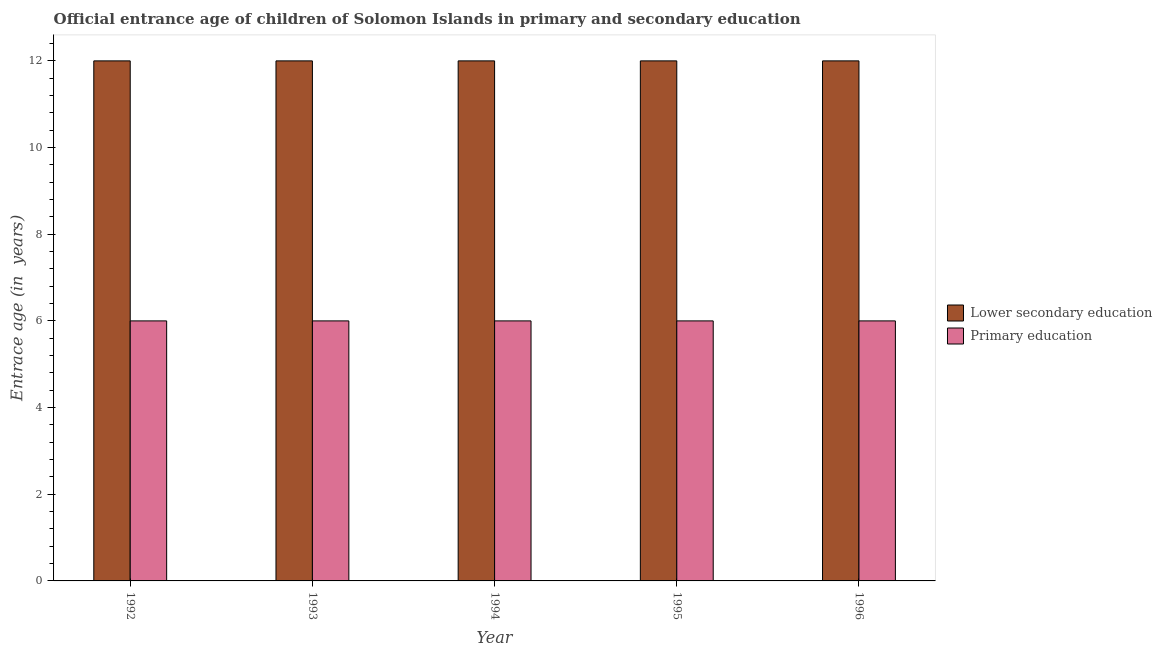How many different coloured bars are there?
Provide a short and direct response. 2. Are the number of bars per tick equal to the number of legend labels?
Offer a very short reply. Yes. What is the entrance age of children in lower secondary education in 1992?
Provide a short and direct response. 12. Across all years, what is the maximum entrance age of chiildren in primary education?
Ensure brevity in your answer.  6. In which year was the entrance age of chiildren in primary education maximum?
Provide a short and direct response. 1992. What is the total entrance age of chiildren in primary education in the graph?
Ensure brevity in your answer.  30. What is the difference between the entrance age of chiildren in primary education in 1994 and the entrance age of children in lower secondary education in 1995?
Ensure brevity in your answer.  0. In the year 1994, what is the difference between the entrance age of children in lower secondary education and entrance age of chiildren in primary education?
Make the answer very short. 0. In how many years, is the entrance age of chiildren in primary education greater than 10.4 years?
Your answer should be very brief. 0. Is the entrance age of chiildren in primary education in 1994 less than that in 1996?
Your answer should be very brief. No. What is the difference between the highest and the lowest entrance age of children in lower secondary education?
Provide a succinct answer. 0. In how many years, is the entrance age of chiildren in primary education greater than the average entrance age of chiildren in primary education taken over all years?
Your answer should be compact. 0. Is the sum of the entrance age of chiildren in primary education in 1994 and 1995 greater than the maximum entrance age of children in lower secondary education across all years?
Give a very brief answer. Yes. What does the 2nd bar from the right in 1993 represents?
Your response must be concise. Lower secondary education. Does the graph contain grids?
Provide a short and direct response. No. How many legend labels are there?
Give a very brief answer. 2. How are the legend labels stacked?
Your answer should be compact. Vertical. What is the title of the graph?
Your response must be concise. Official entrance age of children of Solomon Islands in primary and secondary education. What is the label or title of the Y-axis?
Your response must be concise. Entrace age (in  years). What is the Entrace age (in  years) of Primary education in 1992?
Give a very brief answer. 6. What is the Entrace age (in  years) in Primary education in 1993?
Offer a terse response. 6. What is the Entrace age (in  years) of Lower secondary education in 1995?
Offer a terse response. 12. What is the Entrace age (in  years) of Lower secondary education in 1996?
Ensure brevity in your answer.  12. Across all years, what is the maximum Entrace age (in  years) of Primary education?
Give a very brief answer. 6. What is the difference between the Entrace age (in  years) in Primary education in 1992 and that in 1993?
Make the answer very short. 0. What is the difference between the Entrace age (in  years) of Primary education in 1992 and that in 1994?
Ensure brevity in your answer.  0. What is the difference between the Entrace age (in  years) of Lower secondary education in 1992 and that in 1995?
Offer a terse response. 0. What is the difference between the Entrace age (in  years) of Lower secondary education in 1993 and that in 1994?
Give a very brief answer. 0. What is the difference between the Entrace age (in  years) in Lower secondary education in 1993 and that in 1995?
Offer a terse response. 0. What is the difference between the Entrace age (in  years) of Primary education in 1993 and that in 1995?
Keep it short and to the point. 0. What is the difference between the Entrace age (in  years) in Lower secondary education in 1994 and that in 1995?
Give a very brief answer. 0. What is the difference between the Entrace age (in  years) of Primary education in 1994 and that in 1995?
Ensure brevity in your answer.  0. What is the difference between the Entrace age (in  years) in Lower secondary education in 1994 and that in 1996?
Offer a terse response. 0. What is the difference between the Entrace age (in  years) in Lower secondary education in 1995 and that in 1996?
Your answer should be compact. 0. What is the difference between the Entrace age (in  years) in Primary education in 1995 and that in 1996?
Your answer should be compact. 0. What is the difference between the Entrace age (in  years) of Lower secondary education in 1992 and the Entrace age (in  years) of Primary education in 1993?
Make the answer very short. 6. What is the difference between the Entrace age (in  years) in Lower secondary education in 1992 and the Entrace age (in  years) in Primary education in 1994?
Offer a terse response. 6. What is the difference between the Entrace age (in  years) of Lower secondary education in 1992 and the Entrace age (in  years) of Primary education in 1995?
Your response must be concise. 6. What is the difference between the Entrace age (in  years) in Lower secondary education in 1992 and the Entrace age (in  years) in Primary education in 1996?
Provide a succinct answer. 6. What is the difference between the Entrace age (in  years) of Lower secondary education in 1993 and the Entrace age (in  years) of Primary education in 1994?
Make the answer very short. 6. What is the difference between the Entrace age (in  years) of Lower secondary education in 1995 and the Entrace age (in  years) of Primary education in 1996?
Keep it short and to the point. 6. In the year 1992, what is the difference between the Entrace age (in  years) of Lower secondary education and Entrace age (in  years) of Primary education?
Make the answer very short. 6. In the year 1994, what is the difference between the Entrace age (in  years) of Lower secondary education and Entrace age (in  years) of Primary education?
Ensure brevity in your answer.  6. In the year 1996, what is the difference between the Entrace age (in  years) in Lower secondary education and Entrace age (in  years) in Primary education?
Provide a succinct answer. 6. What is the ratio of the Entrace age (in  years) in Lower secondary education in 1992 to that in 1995?
Your response must be concise. 1. What is the ratio of the Entrace age (in  years) of Primary education in 1992 to that in 1996?
Provide a short and direct response. 1. What is the ratio of the Entrace age (in  years) in Lower secondary education in 1993 to that in 1994?
Offer a very short reply. 1. What is the ratio of the Entrace age (in  years) of Primary education in 1993 to that in 1994?
Keep it short and to the point. 1. What is the ratio of the Entrace age (in  years) of Lower secondary education in 1993 to that in 1995?
Your answer should be very brief. 1. What is the ratio of the Entrace age (in  years) in Lower secondary education in 1993 to that in 1996?
Your answer should be compact. 1. What is the ratio of the Entrace age (in  years) in Primary education in 1994 to that in 1995?
Keep it short and to the point. 1. What is the difference between the highest and the second highest Entrace age (in  years) of Lower secondary education?
Your answer should be very brief. 0. 